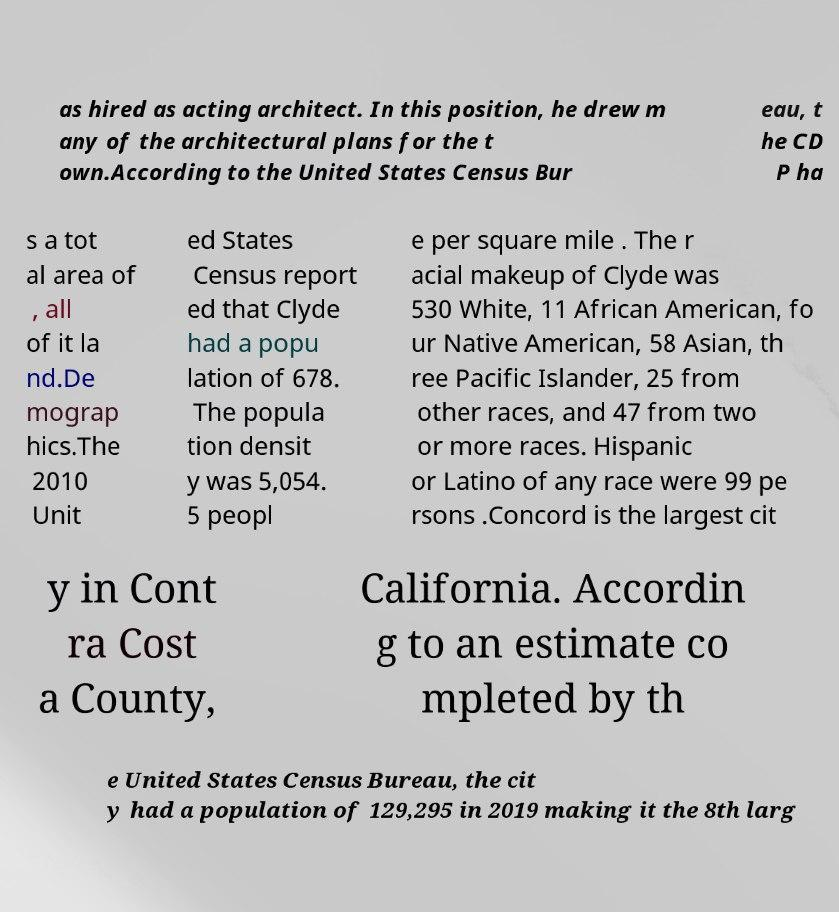Could you assist in decoding the text presented in this image and type it out clearly? as hired as acting architect. In this position, he drew m any of the architectural plans for the t own.According to the United States Census Bur eau, t he CD P ha s a tot al area of , all of it la nd.De mograp hics.The 2010 Unit ed States Census report ed that Clyde had a popu lation of 678. The popula tion densit y was 5,054. 5 peopl e per square mile . The r acial makeup of Clyde was 530 White, 11 African American, fo ur Native American, 58 Asian, th ree Pacific Islander, 25 from other races, and 47 from two or more races. Hispanic or Latino of any race were 99 pe rsons .Concord is the largest cit y in Cont ra Cost a County, California. Accordin g to an estimate co mpleted by th e United States Census Bureau, the cit y had a population of 129,295 in 2019 making it the 8th larg 